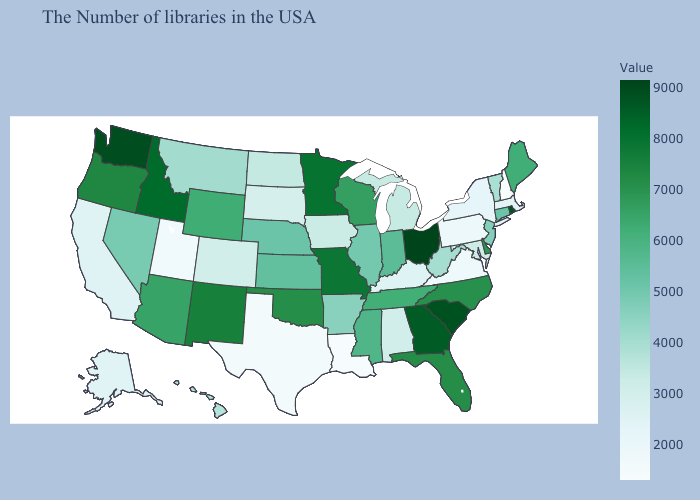Is the legend a continuous bar?
Write a very short answer. Yes. Does Florida have the highest value in the USA?
Give a very brief answer. No. Among the states that border Delaware , which have the lowest value?
Be succinct. Pennsylvania. Among the states that border Washington , does Oregon have the highest value?
Keep it brief. No. Which states have the lowest value in the South?
Keep it brief. Louisiana. Which states hav the highest value in the West?
Short answer required. Washington. Among the states that border New Jersey , which have the highest value?
Answer briefly. Delaware. 